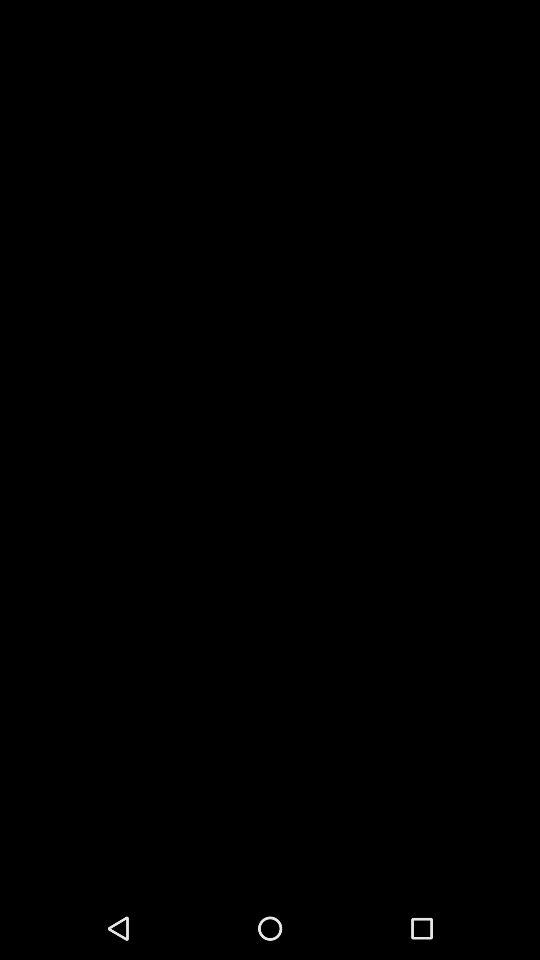How many items have a picture on them?
Answer the question using a single word or phrase. 2 